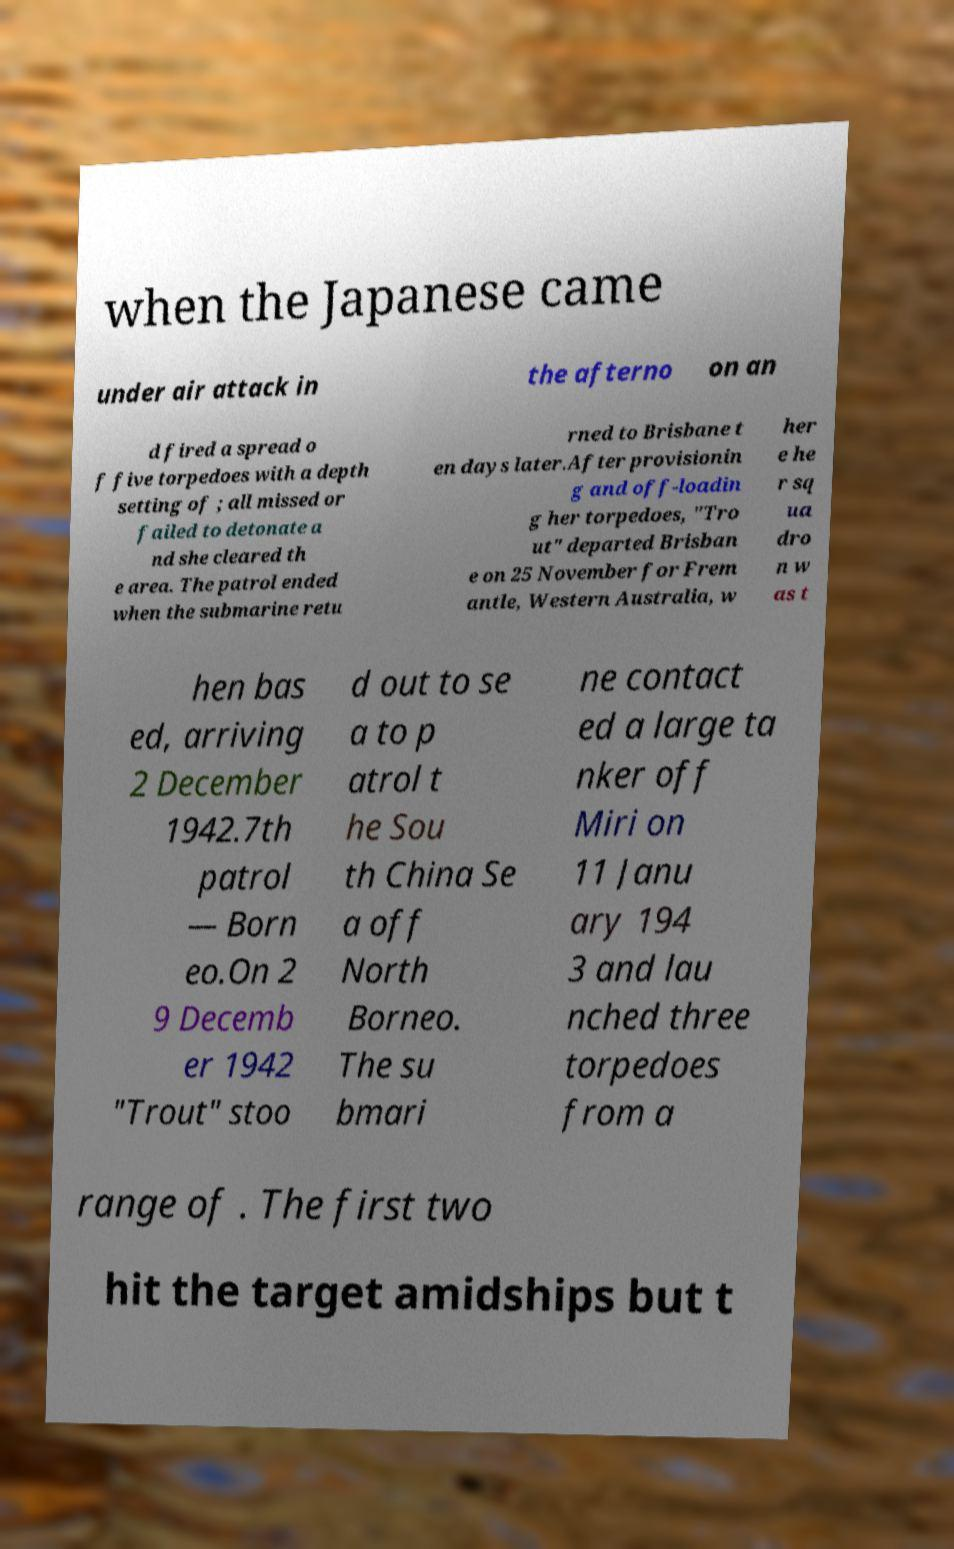Please read and relay the text visible in this image. What does it say? when the Japanese came under air attack in the afterno on an d fired a spread o f five torpedoes with a depth setting of ; all missed or failed to detonate a nd she cleared th e area. The patrol ended when the submarine retu rned to Brisbane t en days later.After provisionin g and off-loadin g her torpedoes, "Tro ut" departed Brisban e on 25 November for Frem antle, Western Australia, w her e he r sq ua dro n w as t hen bas ed, arriving 2 December 1942.7th patrol — Born eo.On 2 9 Decemb er 1942 "Trout" stoo d out to se a to p atrol t he Sou th China Se a off North Borneo. The su bmari ne contact ed a large ta nker off Miri on 11 Janu ary 194 3 and lau nched three torpedoes from a range of . The first two hit the target amidships but t 